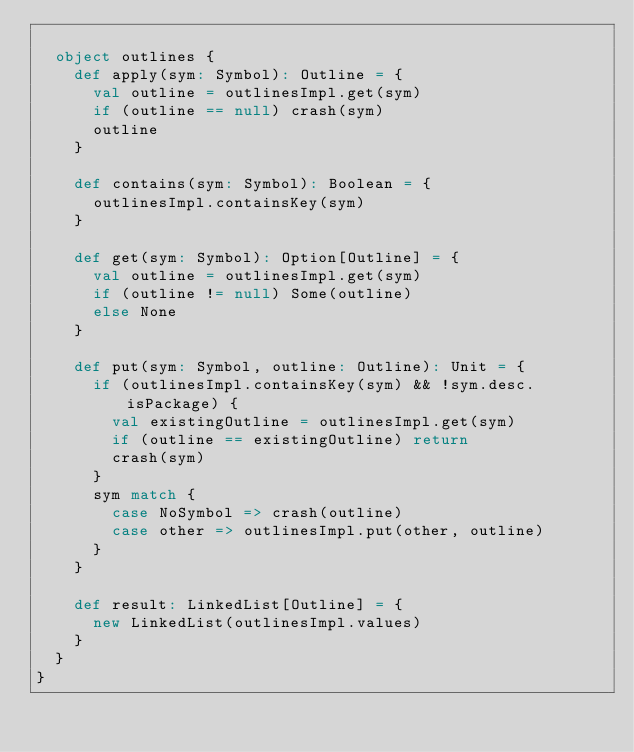<code> <loc_0><loc_0><loc_500><loc_500><_Scala_>
  object outlines {
    def apply(sym: Symbol): Outline = {
      val outline = outlinesImpl.get(sym)
      if (outline == null) crash(sym)
      outline
    }

    def contains(sym: Symbol): Boolean = {
      outlinesImpl.containsKey(sym)
    }

    def get(sym: Symbol): Option[Outline] = {
      val outline = outlinesImpl.get(sym)
      if (outline != null) Some(outline)
      else None
    }

    def put(sym: Symbol, outline: Outline): Unit = {
      if (outlinesImpl.containsKey(sym) && !sym.desc.isPackage) {
        val existingOutline = outlinesImpl.get(sym)
        if (outline == existingOutline) return
        crash(sym)
      }
      sym match {
        case NoSymbol => crash(outline)
        case other => outlinesImpl.put(other, outline)
      }
    }

    def result: LinkedList[Outline] = {
      new LinkedList(outlinesImpl.values)
    }
  }
}
</code> 